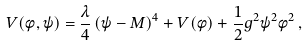Convert formula to latex. <formula><loc_0><loc_0><loc_500><loc_500>V ( \phi , \psi ) = \frac { \lambda } { 4 } \left ( \psi - M \right ) ^ { 4 } + V ( \phi ) + \frac { 1 } { 2 } g ^ { 2 } \psi ^ { 2 } \phi ^ { 2 } \, ,</formula> 